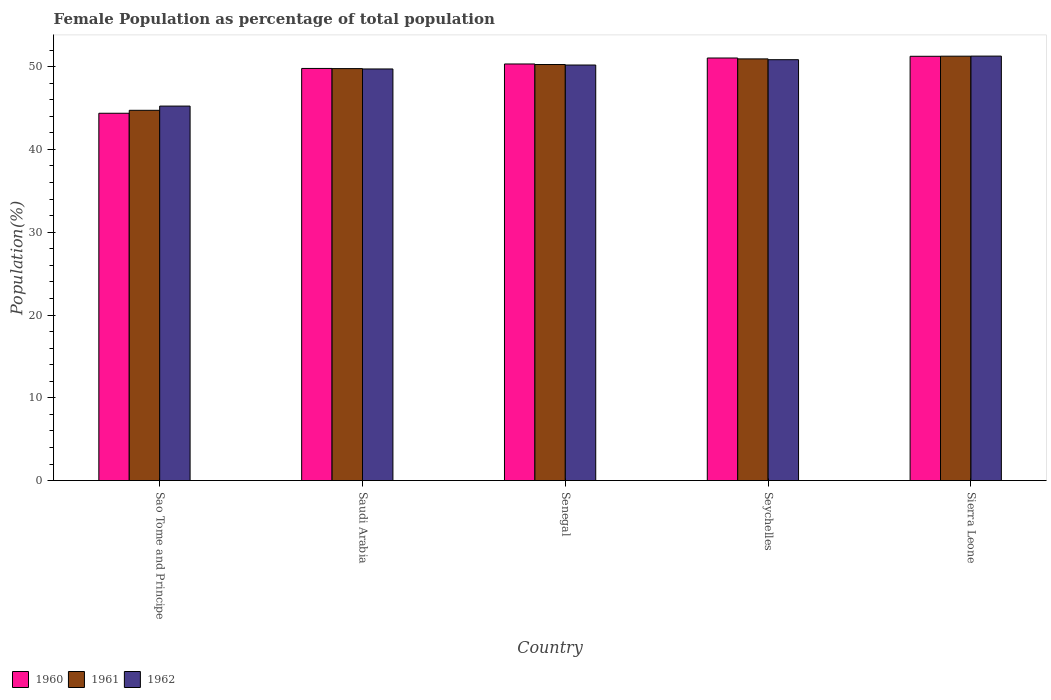How many groups of bars are there?
Your answer should be compact. 5. Are the number of bars per tick equal to the number of legend labels?
Keep it short and to the point. Yes. How many bars are there on the 5th tick from the right?
Provide a short and direct response. 3. What is the label of the 2nd group of bars from the left?
Keep it short and to the point. Saudi Arabia. What is the female population in in 1960 in Seychelles?
Provide a succinct answer. 51.04. Across all countries, what is the maximum female population in in 1962?
Your answer should be very brief. 51.27. Across all countries, what is the minimum female population in in 1962?
Offer a very short reply. 45.24. In which country was the female population in in 1962 maximum?
Your answer should be compact. Sierra Leone. In which country was the female population in in 1961 minimum?
Ensure brevity in your answer.  Sao Tome and Principe. What is the total female population in in 1961 in the graph?
Offer a very short reply. 246.95. What is the difference between the female population in in 1960 in Senegal and that in Seychelles?
Ensure brevity in your answer.  -0.72. What is the difference between the female population in in 1960 in Senegal and the female population in in 1962 in Sao Tome and Principe?
Ensure brevity in your answer.  5.09. What is the average female population in in 1962 per country?
Provide a short and direct response. 49.45. What is the difference between the female population in of/in 1960 and female population in of/in 1962 in Saudi Arabia?
Provide a succinct answer. 0.06. In how many countries, is the female population in in 1960 greater than 2 %?
Make the answer very short. 5. What is the ratio of the female population in in 1961 in Saudi Arabia to that in Seychelles?
Offer a terse response. 0.98. What is the difference between the highest and the second highest female population in in 1960?
Ensure brevity in your answer.  0.72. What is the difference between the highest and the lowest female population in in 1960?
Ensure brevity in your answer.  6.88. Is the sum of the female population in in 1960 in Saudi Arabia and Sierra Leone greater than the maximum female population in in 1962 across all countries?
Your answer should be very brief. Yes. What does the 1st bar from the left in Saudi Arabia represents?
Your answer should be very brief. 1960. Is it the case that in every country, the sum of the female population in in 1960 and female population in in 1961 is greater than the female population in in 1962?
Ensure brevity in your answer.  Yes. How many bars are there?
Your response must be concise. 15. Are all the bars in the graph horizontal?
Ensure brevity in your answer.  No. What is the difference between two consecutive major ticks on the Y-axis?
Give a very brief answer. 10. Does the graph contain any zero values?
Your answer should be compact. No. Does the graph contain grids?
Give a very brief answer. No. How many legend labels are there?
Your response must be concise. 3. How are the legend labels stacked?
Your answer should be compact. Horizontal. What is the title of the graph?
Offer a terse response. Female Population as percentage of total population. What is the label or title of the Y-axis?
Offer a very short reply. Population(%). What is the Population(%) of 1960 in Sao Tome and Principe?
Your answer should be very brief. 44.37. What is the Population(%) of 1961 in Sao Tome and Principe?
Keep it short and to the point. 44.73. What is the Population(%) of 1962 in Sao Tome and Principe?
Provide a short and direct response. 45.24. What is the Population(%) in 1960 in Saudi Arabia?
Keep it short and to the point. 49.78. What is the Population(%) of 1961 in Saudi Arabia?
Provide a succinct answer. 49.76. What is the Population(%) in 1962 in Saudi Arabia?
Give a very brief answer. 49.72. What is the Population(%) of 1960 in Senegal?
Offer a terse response. 50.32. What is the Population(%) in 1961 in Senegal?
Give a very brief answer. 50.26. What is the Population(%) in 1962 in Senegal?
Make the answer very short. 50.2. What is the Population(%) of 1960 in Seychelles?
Keep it short and to the point. 51.04. What is the Population(%) in 1961 in Seychelles?
Ensure brevity in your answer.  50.94. What is the Population(%) in 1962 in Seychelles?
Offer a terse response. 50.84. What is the Population(%) of 1960 in Sierra Leone?
Your answer should be compact. 51.25. What is the Population(%) in 1961 in Sierra Leone?
Ensure brevity in your answer.  51.26. What is the Population(%) in 1962 in Sierra Leone?
Ensure brevity in your answer.  51.27. Across all countries, what is the maximum Population(%) in 1960?
Offer a very short reply. 51.25. Across all countries, what is the maximum Population(%) in 1961?
Provide a short and direct response. 51.26. Across all countries, what is the maximum Population(%) of 1962?
Give a very brief answer. 51.27. Across all countries, what is the minimum Population(%) of 1960?
Offer a very short reply. 44.37. Across all countries, what is the minimum Population(%) in 1961?
Make the answer very short. 44.73. Across all countries, what is the minimum Population(%) in 1962?
Provide a short and direct response. 45.24. What is the total Population(%) in 1960 in the graph?
Make the answer very short. 246.77. What is the total Population(%) of 1961 in the graph?
Provide a short and direct response. 246.95. What is the total Population(%) in 1962 in the graph?
Offer a terse response. 247.26. What is the difference between the Population(%) in 1960 in Sao Tome and Principe and that in Saudi Arabia?
Ensure brevity in your answer.  -5.41. What is the difference between the Population(%) of 1961 in Sao Tome and Principe and that in Saudi Arabia?
Your answer should be compact. -5.04. What is the difference between the Population(%) in 1962 in Sao Tome and Principe and that in Saudi Arabia?
Ensure brevity in your answer.  -4.48. What is the difference between the Population(%) of 1960 in Sao Tome and Principe and that in Senegal?
Your answer should be compact. -5.95. What is the difference between the Population(%) in 1961 in Sao Tome and Principe and that in Senegal?
Your answer should be compact. -5.53. What is the difference between the Population(%) of 1962 in Sao Tome and Principe and that in Senegal?
Offer a terse response. -4.96. What is the difference between the Population(%) in 1960 in Sao Tome and Principe and that in Seychelles?
Your answer should be compact. -6.67. What is the difference between the Population(%) in 1961 in Sao Tome and Principe and that in Seychelles?
Offer a terse response. -6.21. What is the difference between the Population(%) of 1962 in Sao Tome and Principe and that in Seychelles?
Provide a short and direct response. -5.6. What is the difference between the Population(%) of 1960 in Sao Tome and Principe and that in Sierra Leone?
Ensure brevity in your answer.  -6.88. What is the difference between the Population(%) in 1961 in Sao Tome and Principe and that in Sierra Leone?
Ensure brevity in your answer.  -6.54. What is the difference between the Population(%) of 1962 in Sao Tome and Principe and that in Sierra Leone?
Your answer should be compact. -6.04. What is the difference between the Population(%) in 1960 in Saudi Arabia and that in Senegal?
Give a very brief answer. -0.54. What is the difference between the Population(%) of 1961 in Saudi Arabia and that in Senegal?
Offer a terse response. -0.49. What is the difference between the Population(%) of 1962 in Saudi Arabia and that in Senegal?
Provide a short and direct response. -0.48. What is the difference between the Population(%) in 1960 in Saudi Arabia and that in Seychelles?
Your answer should be very brief. -1.26. What is the difference between the Population(%) in 1961 in Saudi Arabia and that in Seychelles?
Ensure brevity in your answer.  -1.17. What is the difference between the Population(%) of 1962 in Saudi Arabia and that in Seychelles?
Your answer should be compact. -1.12. What is the difference between the Population(%) of 1960 in Saudi Arabia and that in Sierra Leone?
Make the answer very short. -1.47. What is the difference between the Population(%) in 1961 in Saudi Arabia and that in Sierra Leone?
Make the answer very short. -1.5. What is the difference between the Population(%) of 1962 in Saudi Arabia and that in Sierra Leone?
Offer a terse response. -1.55. What is the difference between the Population(%) of 1960 in Senegal and that in Seychelles?
Give a very brief answer. -0.72. What is the difference between the Population(%) in 1961 in Senegal and that in Seychelles?
Ensure brevity in your answer.  -0.68. What is the difference between the Population(%) in 1962 in Senegal and that in Seychelles?
Give a very brief answer. -0.64. What is the difference between the Population(%) of 1960 in Senegal and that in Sierra Leone?
Your answer should be compact. -0.93. What is the difference between the Population(%) of 1961 in Senegal and that in Sierra Leone?
Ensure brevity in your answer.  -1.01. What is the difference between the Population(%) in 1962 in Senegal and that in Sierra Leone?
Your answer should be very brief. -1.08. What is the difference between the Population(%) of 1960 in Seychelles and that in Sierra Leone?
Ensure brevity in your answer.  -0.21. What is the difference between the Population(%) in 1961 in Seychelles and that in Sierra Leone?
Your response must be concise. -0.33. What is the difference between the Population(%) of 1962 in Seychelles and that in Sierra Leone?
Your answer should be very brief. -0.43. What is the difference between the Population(%) of 1960 in Sao Tome and Principe and the Population(%) of 1961 in Saudi Arabia?
Provide a short and direct response. -5.39. What is the difference between the Population(%) of 1960 in Sao Tome and Principe and the Population(%) of 1962 in Saudi Arabia?
Provide a short and direct response. -5.35. What is the difference between the Population(%) in 1961 in Sao Tome and Principe and the Population(%) in 1962 in Saudi Arabia?
Your answer should be very brief. -4.99. What is the difference between the Population(%) of 1960 in Sao Tome and Principe and the Population(%) of 1961 in Senegal?
Offer a very short reply. -5.89. What is the difference between the Population(%) of 1960 in Sao Tome and Principe and the Population(%) of 1962 in Senegal?
Your answer should be very brief. -5.83. What is the difference between the Population(%) in 1961 in Sao Tome and Principe and the Population(%) in 1962 in Senegal?
Offer a terse response. -5.47. What is the difference between the Population(%) in 1960 in Sao Tome and Principe and the Population(%) in 1961 in Seychelles?
Provide a short and direct response. -6.57. What is the difference between the Population(%) of 1960 in Sao Tome and Principe and the Population(%) of 1962 in Seychelles?
Offer a terse response. -6.47. What is the difference between the Population(%) in 1961 in Sao Tome and Principe and the Population(%) in 1962 in Seychelles?
Offer a very short reply. -6.11. What is the difference between the Population(%) in 1960 in Sao Tome and Principe and the Population(%) in 1961 in Sierra Leone?
Keep it short and to the point. -6.89. What is the difference between the Population(%) of 1960 in Sao Tome and Principe and the Population(%) of 1962 in Sierra Leone?
Make the answer very short. -6.9. What is the difference between the Population(%) in 1961 in Sao Tome and Principe and the Population(%) in 1962 in Sierra Leone?
Provide a succinct answer. -6.55. What is the difference between the Population(%) of 1960 in Saudi Arabia and the Population(%) of 1961 in Senegal?
Ensure brevity in your answer.  -0.47. What is the difference between the Population(%) in 1960 in Saudi Arabia and the Population(%) in 1962 in Senegal?
Provide a short and direct response. -0.41. What is the difference between the Population(%) of 1961 in Saudi Arabia and the Population(%) of 1962 in Senegal?
Your response must be concise. -0.43. What is the difference between the Population(%) of 1960 in Saudi Arabia and the Population(%) of 1961 in Seychelles?
Your answer should be very brief. -1.15. What is the difference between the Population(%) in 1960 in Saudi Arabia and the Population(%) in 1962 in Seychelles?
Your answer should be compact. -1.06. What is the difference between the Population(%) of 1961 in Saudi Arabia and the Population(%) of 1962 in Seychelles?
Your answer should be very brief. -1.08. What is the difference between the Population(%) of 1960 in Saudi Arabia and the Population(%) of 1961 in Sierra Leone?
Keep it short and to the point. -1.48. What is the difference between the Population(%) in 1960 in Saudi Arabia and the Population(%) in 1962 in Sierra Leone?
Your answer should be compact. -1.49. What is the difference between the Population(%) in 1961 in Saudi Arabia and the Population(%) in 1962 in Sierra Leone?
Your answer should be compact. -1.51. What is the difference between the Population(%) in 1960 in Senegal and the Population(%) in 1961 in Seychelles?
Provide a short and direct response. -0.61. What is the difference between the Population(%) in 1960 in Senegal and the Population(%) in 1962 in Seychelles?
Provide a short and direct response. -0.52. What is the difference between the Population(%) in 1961 in Senegal and the Population(%) in 1962 in Seychelles?
Your answer should be very brief. -0.58. What is the difference between the Population(%) in 1960 in Senegal and the Population(%) in 1961 in Sierra Leone?
Ensure brevity in your answer.  -0.94. What is the difference between the Population(%) of 1960 in Senegal and the Population(%) of 1962 in Sierra Leone?
Keep it short and to the point. -0.95. What is the difference between the Population(%) in 1961 in Senegal and the Population(%) in 1962 in Sierra Leone?
Your response must be concise. -1.02. What is the difference between the Population(%) in 1960 in Seychelles and the Population(%) in 1961 in Sierra Leone?
Your response must be concise. -0.22. What is the difference between the Population(%) of 1960 in Seychelles and the Population(%) of 1962 in Sierra Leone?
Offer a terse response. -0.23. What is the difference between the Population(%) in 1961 in Seychelles and the Population(%) in 1962 in Sierra Leone?
Make the answer very short. -0.34. What is the average Population(%) in 1960 per country?
Your answer should be compact. 49.35. What is the average Population(%) in 1961 per country?
Make the answer very short. 49.39. What is the average Population(%) of 1962 per country?
Ensure brevity in your answer.  49.45. What is the difference between the Population(%) of 1960 and Population(%) of 1961 in Sao Tome and Principe?
Offer a very short reply. -0.36. What is the difference between the Population(%) in 1960 and Population(%) in 1962 in Sao Tome and Principe?
Your answer should be compact. -0.87. What is the difference between the Population(%) of 1961 and Population(%) of 1962 in Sao Tome and Principe?
Your answer should be compact. -0.51. What is the difference between the Population(%) in 1960 and Population(%) in 1961 in Saudi Arabia?
Provide a short and direct response. 0.02. What is the difference between the Population(%) of 1960 and Population(%) of 1962 in Saudi Arabia?
Make the answer very short. 0.06. What is the difference between the Population(%) in 1961 and Population(%) in 1962 in Saudi Arabia?
Ensure brevity in your answer.  0.04. What is the difference between the Population(%) in 1960 and Population(%) in 1961 in Senegal?
Keep it short and to the point. 0.07. What is the difference between the Population(%) in 1960 and Population(%) in 1962 in Senegal?
Give a very brief answer. 0.13. What is the difference between the Population(%) in 1961 and Population(%) in 1962 in Senegal?
Provide a short and direct response. 0.06. What is the difference between the Population(%) of 1960 and Population(%) of 1961 in Seychelles?
Provide a succinct answer. 0.11. What is the difference between the Population(%) in 1960 and Population(%) in 1962 in Seychelles?
Your answer should be compact. 0.2. What is the difference between the Population(%) of 1961 and Population(%) of 1962 in Seychelles?
Offer a very short reply. 0.1. What is the difference between the Population(%) of 1960 and Population(%) of 1961 in Sierra Leone?
Your answer should be very brief. -0.01. What is the difference between the Population(%) in 1960 and Population(%) in 1962 in Sierra Leone?
Offer a very short reply. -0.02. What is the difference between the Population(%) of 1961 and Population(%) of 1962 in Sierra Leone?
Your answer should be very brief. -0.01. What is the ratio of the Population(%) in 1960 in Sao Tome and Principe to that in Saudi Arabia?
Offer a very short reply. 0.89. What is the ratio of the Population(%) of 1961 in Sao Tome and Principe to that in Saudi Arabia?
Your answer should be very brief. 0.9. What is the ratio of the Population(%) of 1962 in Sao Tome and Principe to that in Saudi Arabia?
Your answer should be compact. 0.91. What is the ratio of the Population(%) of 1960 in Sao Tome and Principe to that in Senegal?
Your response must be concise. 0.88. What is the ratio of the Population(%) of 1961 in Sao Tome and Principe to that in Senegal?
Ensure brevity in your answer.  0.89. What is the ratio of the Population(%) in 1962 in Sao Tome and Principe to that in Senegal?
Provide a short and direct response. 0.9. What is the ratio of the Population(%) in 1960 in Sao Tome and Principe to that in Seychelles?
Your answer should be very brief. 0.87. What is the ratio of the Population(%) of 1961 in Sao Tome and Principe to that in Seychelles?
Offer a terse response. 0.88. What is the ratio of the Population(%) in 1962 in Sao Tome and Principe to that in Seychelles?
Your response must be concise. 0.89. What is the ratio of the Population(%) in 1960 in Sao Tome and Principe to that in Sierra Leone?
Your response must be concise. 0.87. What is the ratio of the Population(%) of 1961 in Sao Tome and Principe to that in Sierra Leone?
Your answer should be compact. 0.87. What is the ratio of the Population(%) in 1962 in Sao Tome and Principe to that in Sierra Leone?
Your answer should be compact. 0.88. What is the ratio of the Population(%) in 1960 in Saudi Arabia to that in Senegal?
Your response must be concise. 0.99. What is the ratio of the Population(%) of 1961 in Saudi Arabia to that in Senegal?
Your answer should be compact. 0.99. What is the ratio of the Population(%) of 1960 in Saudi Arabia to that in Seychelles?
Provide a short and direct response. 0.98. What is the ratio of the Population(%) in 1961 in Saudi Arabia to that in Seychelles?
Your answer should be very brief. 0.98. What is the ratio of the Population(%) of 1960 in Saudi Arabia to that in Sierra Leone?
Offer a very short reply. 0.97. What is the ratio of the Population(%) in 1961 in Saudi Arabia to that in Sierra Leone?
Your response must be concise. 0.97. What is the ratio of the Population(%) of 1962 in Saudi Arabia to that in Sierra Leone?
Offer a very short reply. 0.97. What is the ratio of the Population(%) in 1960 in Senegal to that in Seychelles?
Your response must be concise. 0.99. What is the ratio of the Population(%) in 1961 in Senegal to that in Seychelles?
Your answer should be very brief. 0.99. What is the ratio of the Population(%) in 1962 in Senegal to that in Seychelles?
Your response must be concise. 0.99. What is the ratio of the Population(%) of 1960 in Senegal to that in Sierra Leone?
Your answer should be very brief. 0.98. What is the ratio of the Population(%) in 1961 in Senegal to that in Sierra Leone?
Provide a succinct answer. 0.98. What is the ratio of the Population(%) of 1961 in Seychelles to that in Sierra Leone?
Provide a succinct answer. 0.99. What is the difference between the highest and the second highest Population(%) in 1960?
Ensure brevity in your answer.  0.21. What is the difference between the highest and the second highest Population(%) of 1961?
Provide a succinct answer. 0.33. What is the difference between the highest and the second highest Population(%) in 1962?
Ensure brevity in your answer.  0.43. What is the difference between the highest and the lowest Population(%) in 1960?
Offer a terse response. 6.88. What is the difference between the highest and the lowest Population(%) of 1961?
Ensure brevity in your answer.  6.54. What is the difference between the highest and the lowest Population(%) in 1962?
Make the answer very short. 6.04. 